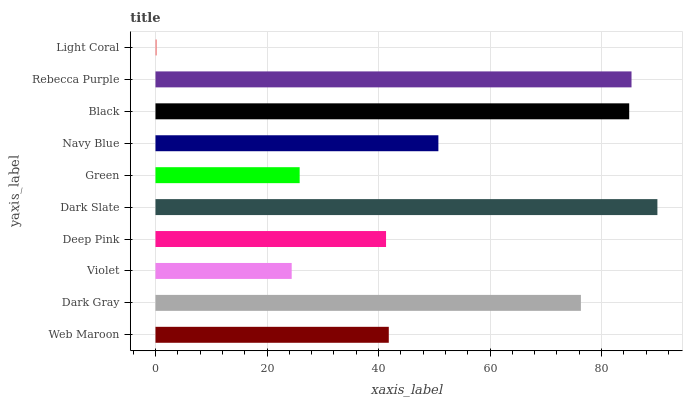Is Light Coral the minimum?
Answer yes or no. Yes. Is Dark Slate the maximum?
Answer yes or no. Yes. Is Dark Gray the minimum?
Answer yes or no. No. Is Dark Gray the maximum?
Answer yes or no. No. Is Dark Gray greater than Web Maroon?
Answer yes or no. Yes. Is Web Maroon less than Dark Gray?
Answer yes or no. Yes. Is Web Maroon greater than Dark Gray?
Answer yes or no. No. Is Dark Gray less than Web Maroon?
Answer yes or no. No. Is Navy Blue the high median?
Answer yes or no. Yes. Is Web Maroon the low median?
Answer yes or no. Yes. Is Green the high median?
Answer yes or no. No. Is Dark Gray the low median?
Answer yes or no. No. 